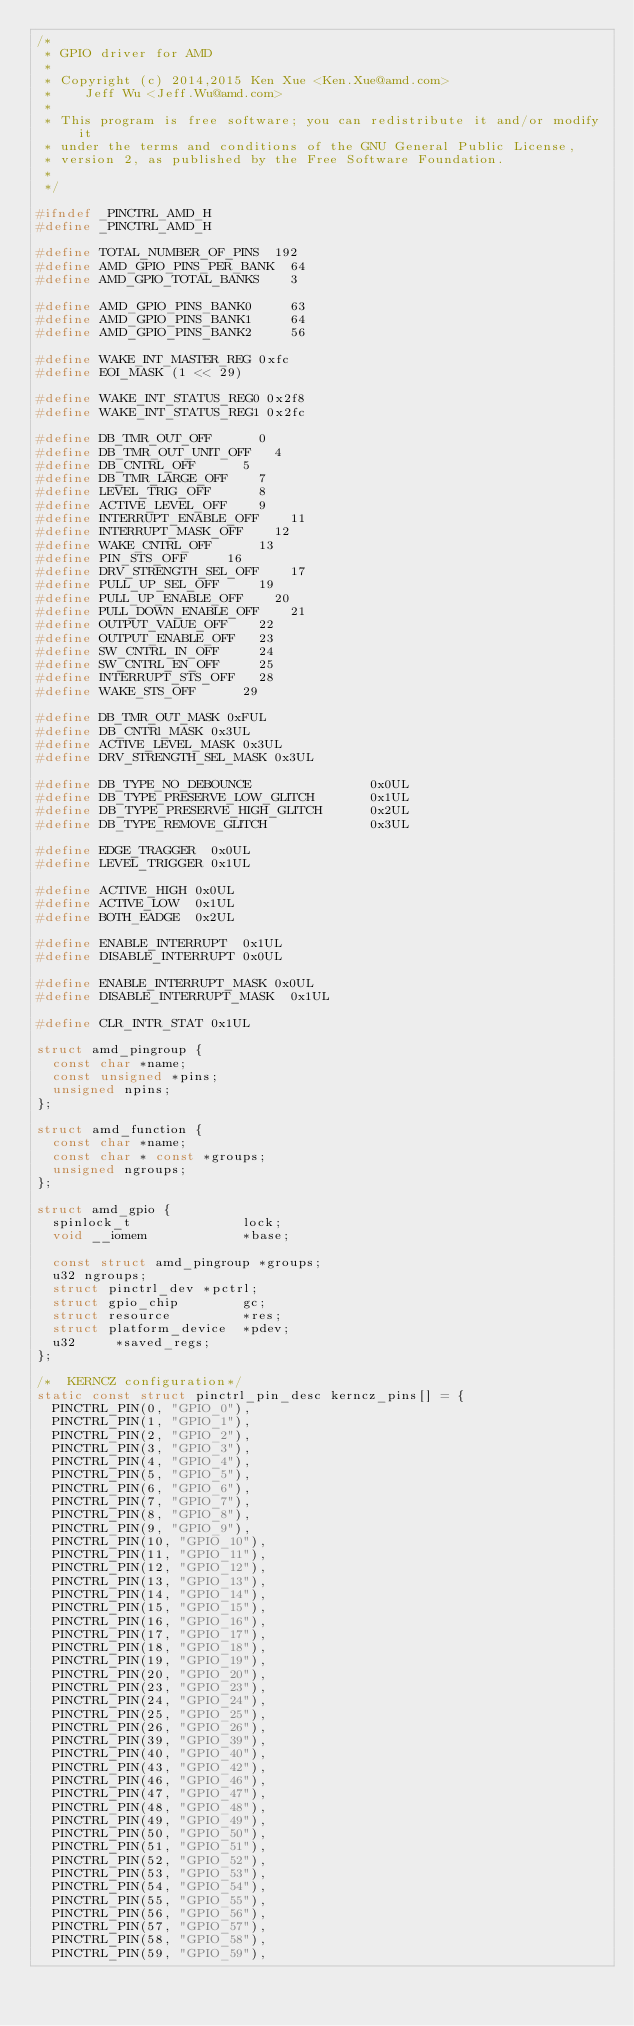<code> <loc_0><loc_0><loc_500><loc_500><_C_>/*
 * GPIO driver for AMD
 *
 * Copyright (c) 2014,2015 Ken Xue <Ken.Xue@amd.com>
 *		Jeff Wu <Jeff.Wu@amd.com>
 *
 * This program is free software; you can redistribute it and/or modify it
 * under the terms and conditions of the GNU General Public License,
 * version 2, as published by the Free Software Foundation.
 *
 */

#ifndef _PINCTRL_AMD_H
#define _PINCTRL_AMD_H

#define TOTAL_NUMBER_OF_PINS	192
#define AMD_GPIO_PINS_PER_BANK  64
#define AMD_GPIO_TOTAL_BANKS    3

#define AMD_GPIO_PINS_BANK0     63
#define AMD_GPIO_PINS_BANK1     64
#define AMD_GPIO_PINS_BANK2     56

#define WAKE_INT_MASTER_REG 0xfc
#define EOI_MASK (1 << 29)

#define WAKE_INT_STATUS_REG0 0x2f8
#define WAKE_INT_STATUS_REG1 0x2fc

#define DB_TMR_OUT_OFF			0
#define DB_TMR_OUT_UNIT_OFF		4
#define DB_CNTRL_OFF			5
#define DB_TMR_LARGE_OFF		7
#define LEVEL_TRIG_OFF			8
#define ACTIVE_LEVEL_OFF		9
#define INTERRUPT_ENABLE_OFF		11
#define INTERRUPT_MASK_OFF		12
#define WAKE_CNTRL_OFF			13
#define PIN_STS_OFF			16
#define DRV_STRENGTH_SEL_OFF		17
#define PULL_UP_SEL_OFF			19
#define PULL_UP_ENABLE_OFF		20
#define PULL_DOWN_ENABLE_OFF		21
#define OUTPUT_VALUE_OFF		22
#define OUTPUT_ENABLE_OFF		23
#define SW_CNTRL_IN_OFF			24
#define SW_CNTRL_EN_OFF			25
#define INTERRUPT_STS_OFF		28
#define WAKE_STS_OFF			29

#define DB_TMR_OUT_MASK	0xFUL
#define DB_CNTRl_MASK	0x3UL
#define ACTIVE_LEVEL_MASK	0x3UL
#define DRV_STRENGTH_SEL_MASK	0x3UL

#define DB_TYPE_NO_DEBOUNCE               0x0UL
#define DB_TYPE_PRESERVE_LOW_GLITCH       0x1UL
#define DB_TYPE_PRESERVE_HIGH_GLITCH      0x2UL
#define DB_TYPE_REMOVE_GLITCH             0x3UL

#define EDGE_TRAGGER	0x0UL
#define LEVEL_TRIGGER	0x1UL

#define ACTIVE_HIGH	0x0UL
#define ACTIVE_LOW	0x1UL
#define BOTH_EADGE	0x2UL

#define ENABLE_INTERRUPT	0x1UL
#define DISABLE_INTERRUPT	0x0UL

#define ENABLE_INTERRUPT_MASK	0x0UL
#define DISABLE_INTERRUPT_MASK	0x1UL

#define CLR_INTR_STAT	0x1UL

struct amd_pingroup {
	const char *name;
	const unsigned *pins;
	unsigned npins;
};

struct amd_function {
	const char *name;
	const char * const *groups;
	unsigned ngroups;
};

struct amd_gpio {
	spinlock_t              lock;
	void __iomem            *base;

	const struct amd_pingroup *groups;
	u32 ngroups;
	struct pinctrl_dev *pctrl;
	struct gpio_chip        gc;
	struct resource         *res;
	struct platform_device  *pdev;
	u32			*saved_regs;
};

/*  KERNCZ configuration*/
static const struct pinctrl_pin_desc kerncz_pins[] = {
	PINCTRL_PIN(0, "GPIO_0"),
	PINCTRL_PIN(1, "GPIO_1"),
	PINCTRL_PIN(2, "GPIO_2"),
	PINCTRL_PIN(3, "GPIO_3"),
	PINCTRL_PIN(4, "GPIO_4"),
	PINCTRL_PIN(5, "GPIO_5"),
	PINCTRL_PIN(6, "GPIO_6"),
	PINCTRL_PIN(7, "GPIO_7"),
	PINCTRL_PIN(8, "GPIO_8"),
	PINCTRL_PIN(9, "GPIO_9"),
	PINCTRL_PIN(10, "GPIO_10"),
	PINCTRL_PIN(11, "GPIO_11"),
	PINCTRL_PIN(12, "GPIO_12"),
	PINCTRL_PIN(13, "GPIO_13"),
	PINCTRL_PIN(14, "GPIO_14"),
	PINCTRL_PIN(15, "GPIO_15"),
	PINCTRL_PIN(16, "GPIO_16"),
	PINCTRL_PIN(17, "GPIO_17"),
	PINCTRL_PIN(18, "GPIO_18"),
	PINCTRL_PIN(19, "GPIO_19"),
	PINCTRL_PIN(20, "GPIO_20"),
	PINCTRL_PIN(23, "GPIO_23"),
	PINCTRL_PIN(24, "GPIO_24"),
	PINCTRL_PIN(25, "GPIO_25"),
	PINCTRL_PIN(26, "GPIO_26"),
	PINCTRL_PIN(39, "GPIO_39"),
	PINCTRL_PIN(40, "GPIO_40"),
	PINCTRL_PIN(43, "GPIO_42"),
	PINCTRL_PIN(46, "GPIO_46"),
	PINCTRL_PIN(47, "GPIO_47"),
	PINCTRL_PIN(48, "GPIO_48"),
	PINCTRL_PIN(49, "GPIO_49"),
	PINCTRL_PIN(50, "GPIO_50"),
	PINCTRL_PIN(51, "GPIO_51"),
	PINCTRL_PIN(52, "GPIO_52"),
	PINCTRL_PIN(53, "GPIO_53"),
	PINCTRL_PIN(54, "GPIO_54"),
	PINCTRL_PIN(55, "GPIO_55"),
	PINCTRL_PIN(56, "GPIO_56"),
	PINCTRL_PIN(57, "GPIO_57"),
	PINCTRL_PIN(58, "GPIO_58"),
	PINCTRL_PIN(59, "GPIO_59"),</code> 